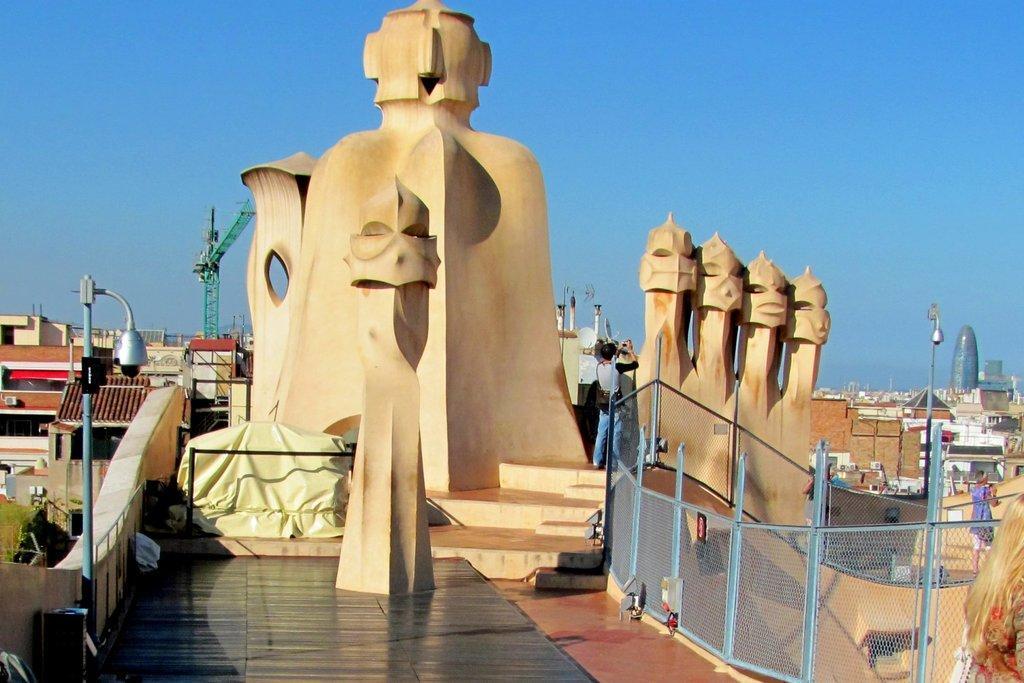In one or two sentences, can you explain what this image depicts? In the center of the image we can see statue, buildings, poles, tower. At the bottom of the image we can see floor, mesh, some persons, board, wall, roof. At the top of the image there is a sky. 